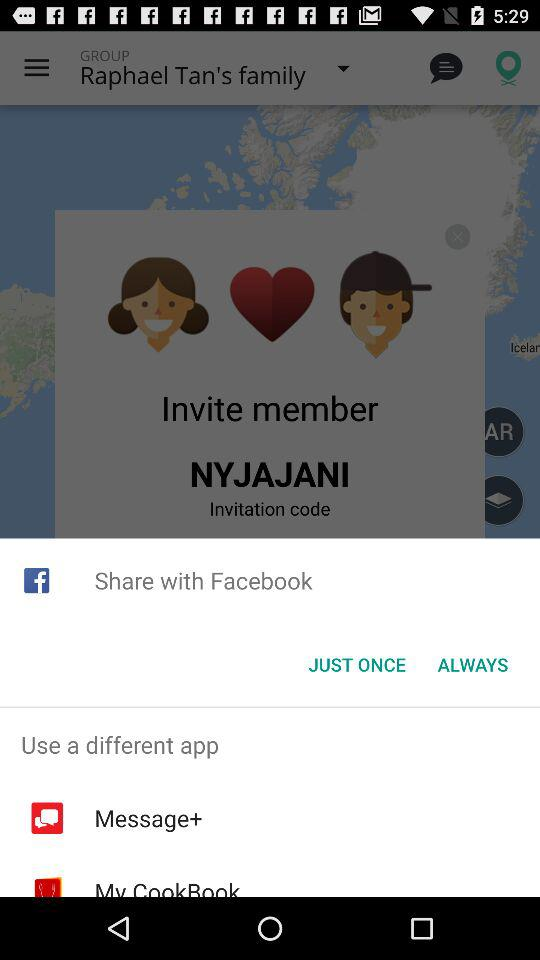To whom am I sending an invitation? You are sending an invitation to Nyjajani. 